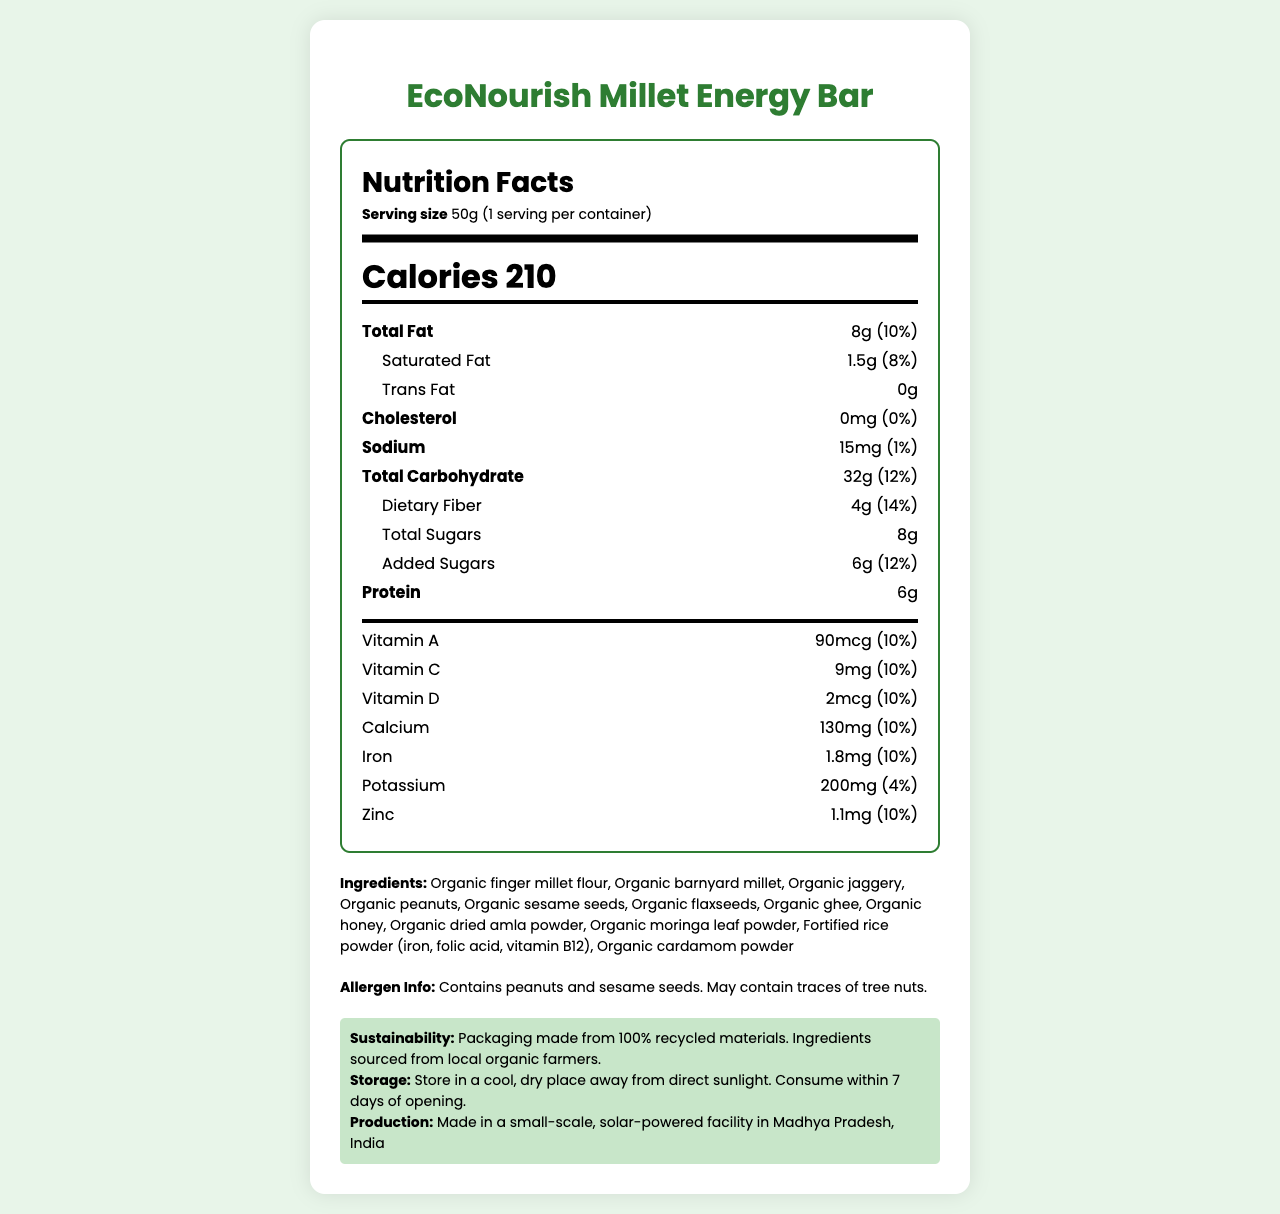What are the total calories per serving? The nutrition label states that there are 210 calories per serving.
Answer: 210 What is the serving size of the EcoNourish Millet Energy Bar? The serving size listed on the document is 50 grams.
Answer: 50g List the micronutrients mentioned in the nutrition facts. These are listed under the nutrient section with their amounts and daily values.
Answer: Vitamin A, Vitamin C, Vitamin D, Calcium, Iron, Potassium, Zinc Does the EcoNourish Millet Energy Bar contain any trans fat? The nutrition information specifically states "Trans Fat 0g".
Answer: No What percentage of the daily value of fiber does one serving provide? The document indicates that one serving provides 14% of the daily value of dietary fiber.
Answer: 14% Which of the following ingredients is not part of the EcoNourish Millet Energy Bar? A. Organic jaggery B. Organic finger millet flour C. Palm oil D. Organic dried amla powder Palm oil is not listed in the ingredients, while the other options are.
Answer: C. Palm oil What is the amount of added sugars in one serving of the energy bar? The nutrition facts label shows that there are 6 grams of added sugars.
Answer: 6g Is the EcoNourish Millet Energy Bar vegan-friendly? The provided data does not clarify whether all ingredients are vegan, although it mentions organic ghee which is not vegan.
Answer: Not enough information How should the EcoNourish Millet Energy Bar be stored after opening? These storage instructions are explicitly stated in the document.
Answer: Store in a cool, dry place away from direct sunlight. Consume within 7 days of opening. Where is the EcoNourish Millet Energy Bar produced? The production location mentioned is a small-scale, solar-powered facility in Madhya Pradesh, India.
Answer: Madhya Pradesh, India What sustainability measures does the product note? The document includes details on sustainable packaging and sourcing.
Answer: Packaging made from 100% recycled materials. Ingredients sourced from local organic farmers. What is the total amount of protein in one serving? The nutrition label lists the protein content as 6 grams.
Answer: 6g Summarize the main information provided in the document. The document provides detailed nutritional information, ingredient list, allergen warnings, sustainability initiatives, and storage guidance for the EcoNourish Millet Energy Bar.
Answer: The EcoNourish Millet Energy Bar is a homemade, organic, millet-based energy bar enriched with essential micronutrients. Each 50g serving offers 210 calories, 8g total fat, 32g carbohydrates, 6g protein, and various vitamins and minerals. It contains several organic ingredients and allergen information, and highlights sustainability practices like 100% recycled packaging and locally sourced ingredients. The product is made in a small-scale, solar-powered facility in Madhya Pradesh, India, and has specific storage instructions. 